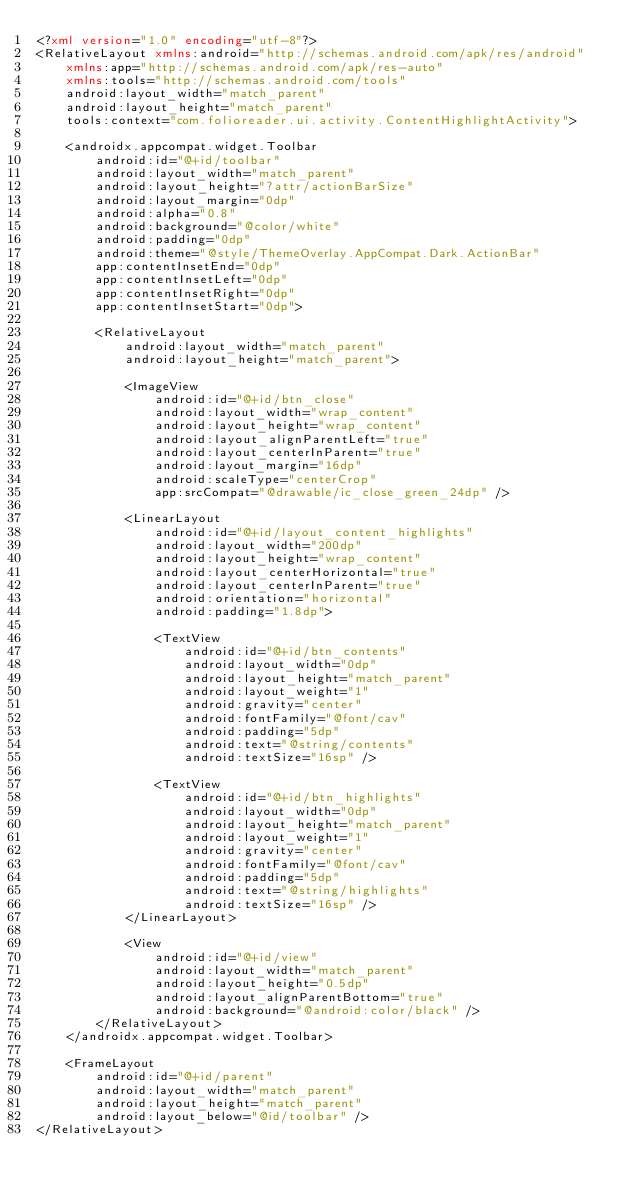<code> <loc_0><loc_0><loc_500><loc_500><_XML_><?xml version="1.0" encoding="utf-8"?>
<RelativeLayout xmlns:android="http://schemas.android.com/apk/res/android"
    xmlns:app="http://schemas.android.com/apk/res-auto"
    xmlns:tools="http://schemas.android.com/tools"
    android:layout_width="match_parent"
    android:layout_height="match_parent"
    tools:context="com.folioreader.ui.activity.ContentHighlightActivity">

    <androidx.appcompat.widget.Toolbar
        android:id="@+id/toolbar"
        android:layout_width="match_parent"
        android:layout_height="?attr/actionBarSize"
        android:layout_margin="0dp"
        android:alpha="0.8"
        android:background="@color/white"
        android:padding="0dp"
        android:theme="@style/ThemeOverlay.AppCompat.Dark.ActionBar"
        app:contentInsetEnd="0dp"
        app:contentInsetLeft="0dp"
        app:contentInsetRight="0dp"
        app:contentInsetStart="0dp">

        <RelativeLayout
            android:layout_width="match_parent"
            android:layout_height="match_parent">

            <ImageView
                android:id="@+id/btn_close"
                android:layout_width="wrap_content"
                android:layout_height="wrap_content"
                android:layout_alignParentLeft="true"
                android:layout_centerInParent="true"
                android:layout_margin="16dp"
                android:scaleType="centerCrop"
                app:srcCompat="@drawable/ic_close_green_24dp" />

            <LinearLayout
                android:id="@+id/layout_content_highlights"
                android:layout_width="200dp"
                android:layout_height="wrap_content"
                android:layout_centerHorizontal="true"
                android:layout_centerInParent="true"
                android:orientation="horizontal"
                android:padding="1.8dp">

                <TextView
                    android:id="@+id/btn_contents"
                    android:layout_width="0dp"
                    android:layout_height="match_parent"
                    android:layout_weight="1"
                    android:gravity="center"
                    android:fontFamily="@font/cav"
                    android:padding="5dp"
                    android:text="@string/contents"
                    android:textSize="16sp" />

                <TextView
                    android:id="@+id/btn_highlights"
                    android:layout_width="0dp"
                    android:layout_height="match_parent"
                    android:layout_weight="1"
                    android:gravity="center"
                    android:fontFamily="@font/cav"
                    android:padding="5dp"
                    android:text="@string/highlights"
                    android:textSize="16sp" />
            </LinearLayout>

            <View
                android:id="@+id/view"
                android:layout_width="match_parent"
                android:layout_height="0.5dp"
                android:layout_alignParentBottom="true"
                android:background="@android:color/black" />
        </RelativeLayout>
    </androidx.appcompat.widget.Toolbar>

    <FrameLayout
        android:id="@+id/parent"
        android:layout_width="match_parent"
        android:layout_height="match_parent"
        android:layout_below="@id/toolbar" />
</RelativeLayout>
</code> 